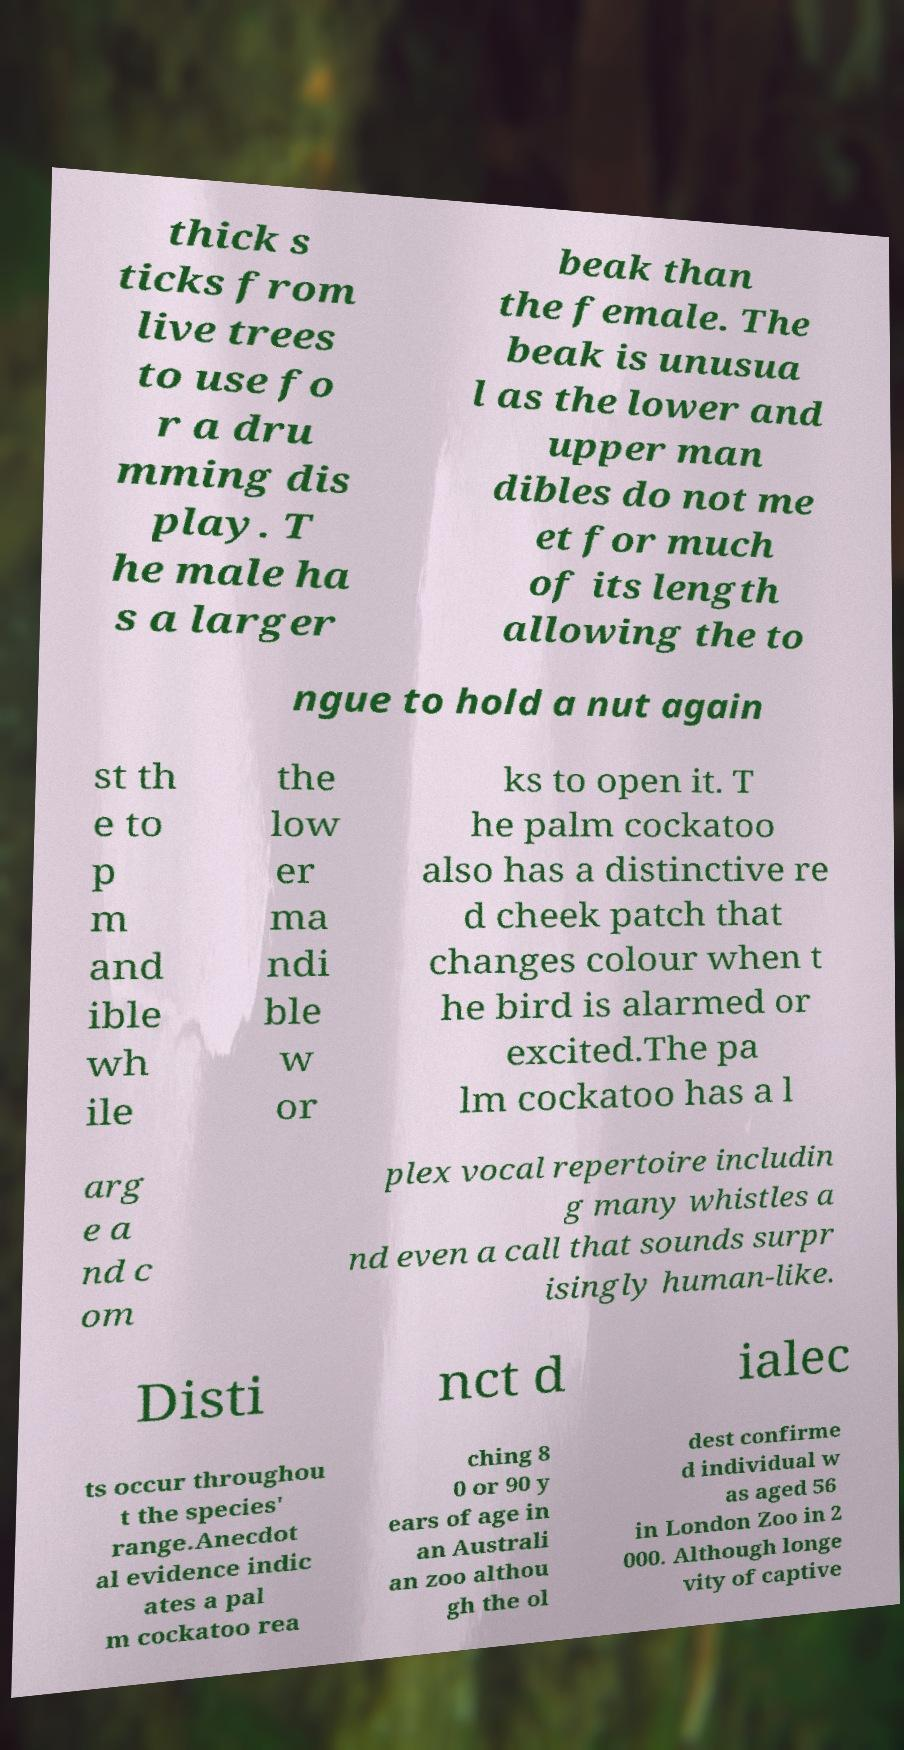For documentation purposes, I need the text within this image transcribed. Could you provide that? thick s ticks from live trees to use fo r a dru mming dis play. T he male ha s a larger beak than the female. The beak is unusua l as the lower and upper man dibles do not me et for much of its length allowing the to ngue to hold a nut again st th e to p m and ible wh ile the low er ma ndi ble w or ks to open it. T he palm cockatoo also has a distinctive re d cheek patch that changes colour when t he bird is alarmed or excited.The pa lm cockatoo has a l arg e a nd c om plex vocal repertoire includin g many whistles a nd even a call that sounds surpr isingly human-like. Disti nct d ialec ts occur throughou t the species' range.Anecdot al evidence indic ates a pal m cockatoo rea ching 8 0 or 90 y ears of age in an Australi an zoo althou gh the ol dest confirme d individual w as aged 56 in London Zoo in 2 000. Although longe vity of captive 